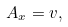<formula> <loc_0><loc_0><loc_500><loc_500>A _ { x } = v ,</formula> 